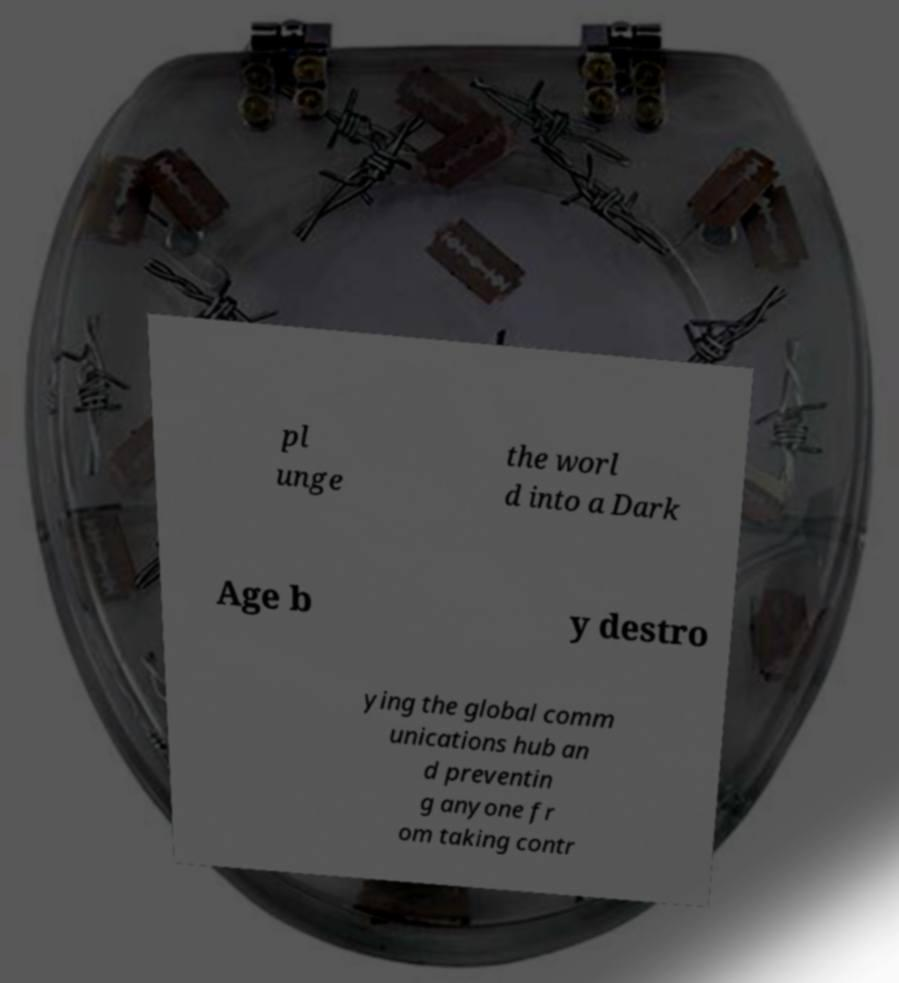Could you extract and type out the text from this image? pl unge the worl d into a Dark Age b y destro ying the global comm unications hub an d preventin g anyone fr om taking contr 